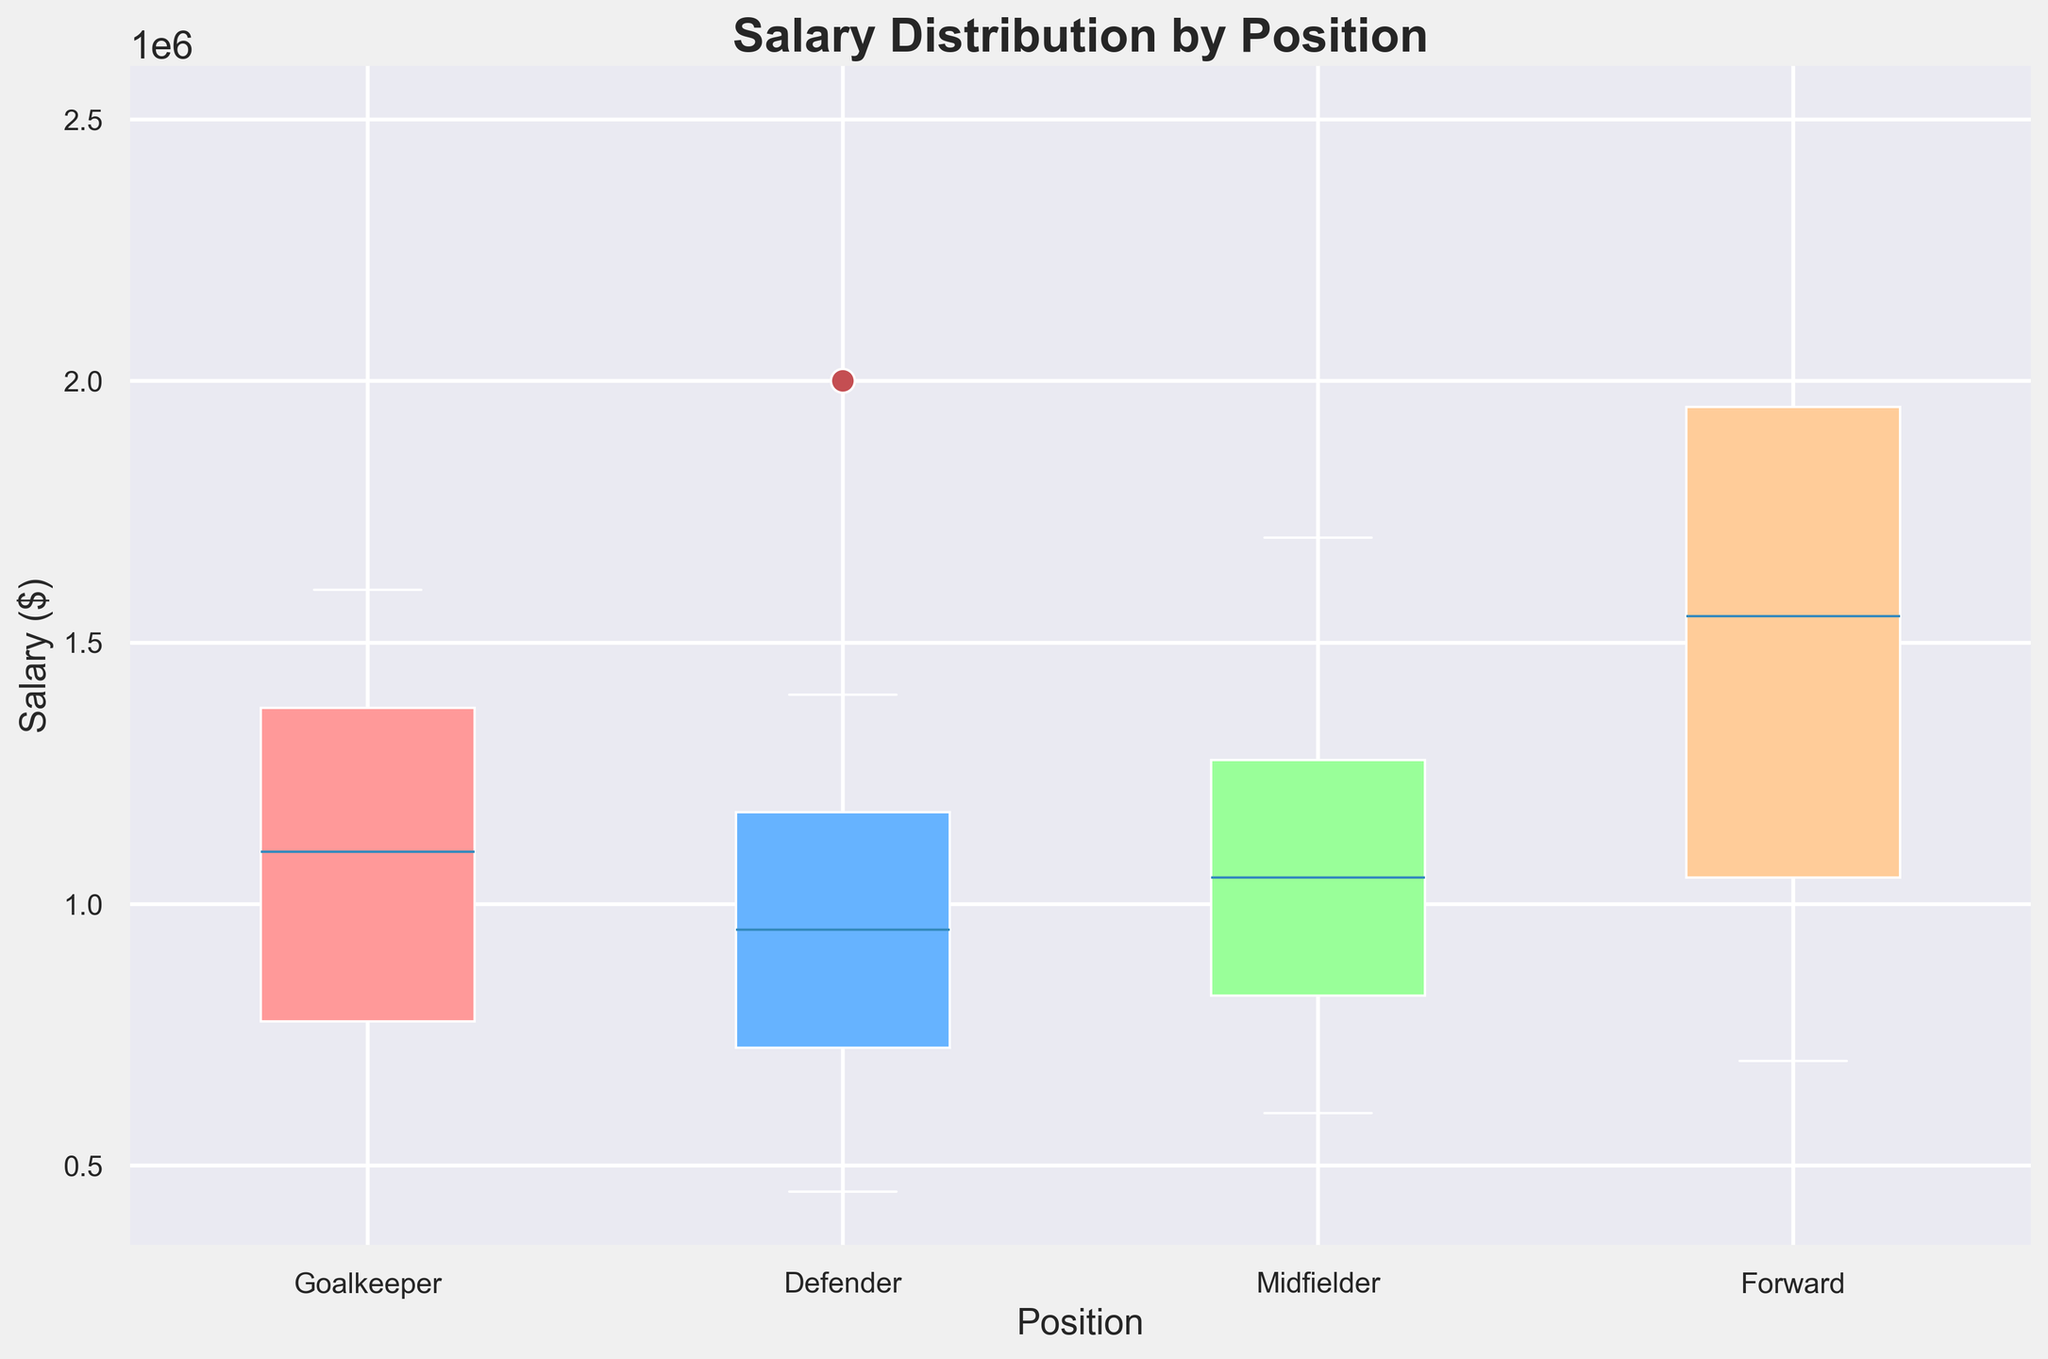Which position has the highest median salary? The median salary is indicated by the line inside each box in a box plot. By comparing these lines across all positions, the Forward position has the highest median salary.
Answer: Forward What is the range of salaries for Midfielders? The range of a box plot is determined by the whiskers (minimum and maximum values). For Midfielders, the minimum salary is $600,000, and the maximum salary is $1,700,000. The range is $1,700,000 - $600,000.
Answer: $1,100,000 Which position has the largest interquartile range (IQR) of salaries? The interquartile range (IQR) is the difference between the upper quartile (75th percentile) and the lower quartile (25th percentile) of the data. In the box plot, the length of the box represents the IQR. By visually inspecting the boxes, Forwards have the largest IQR.
Answer: Forward How does the median salary for Defenders compare to the median salary for Goalkeepers? The median salary is represented by the line inside each box. By comparing the medians directly, the median salary for Goalkeepers is higher than the median salary for Defenders.
Answer: Goalkeepers have a higher median salary than Defenders What is the minimum salary for Forwards? The minimum salary in a box plot is indicated by the lower whisker. Forwards have a minimum salary represented by the lower end of the whisker, which is $700,000.
Answer: $700,000 Which position has the smallest spread (difference) between the minimum and maximum salaries? The spread is the range between the minimum and maximum salaries represented by the whiskers. By comparing these visually, Goalkeepers have the smallest spread.
Answer: Goalkeeper How does the third quartile (75th percentile) salary for Midfielders compare to that of Defenders? The third quartile is represented by the top edge of the box. By comparing these lines, the third quartile salary for Midfielders is lower than for Defenders.
Answer: Defenders' third quartile is higher than Midfielders' Among all the positions, which has the highest maximum salary? The maximum salary is indicated by the upper whisker. By inspecting the whiskers, Forwards have the highest maximum salary.
Answer: Forward What is the median salary difference between Goalkeepers and Forwards? The median salary is represented by the line inside each box. Calculate the difference between the medians of Goalkeepers and Forwards. The median salary difference is approximately $1,100,000 - $1,300,000 = -$200,000.
Answer: -$200,000 How does the interquartile range (IQR) of Defenders compare to the IQR of Midfielders? The IQR is the box length, representing the spread between the 25th and 75th percentiles. By comparing the box lengths, Defenders have a smaller IQR compared to Midfielders.
Answer: Midfielders have a larger IQR than Defenders 